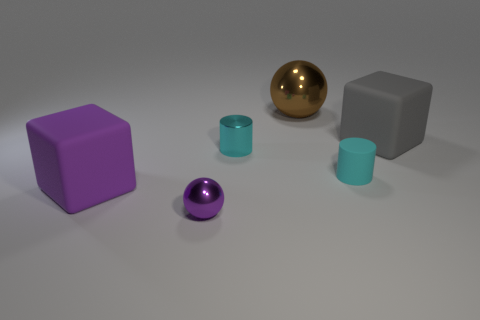How many things are things to the left of the cyan shiny cylinder or metal spheres behind the gray thing?
Make the answer very short. 3. Is the number of purple balls right of the tiny matte object the same as the number of big things in front of the big metal sphere?
Make the answer very short. No. There is a thing that is in front of the large rubber thing in front of the small metallic cylinder; what shape is it?
Offer a very short reply. Sphere. Are there any large purple rubber objects of the same shape as the big gray object?
Your response must be concise. Yes. What number of purple objects are there?
Provide a succinct answer. 2. Is the cube that is to the left of the brown shiny object made of the same material as the big gray block?
Keep it short and to the point. Yes. Is there another thing that has the same size as the gray object?
Provide a short and direct response. Yes. There is a large brown metal thing; is its shape the same as the shiny thing on the left side of the cyan metal cylinder?
Your response must be concise. Yes. There is a large rubber object to the left of the large gray matte block behind the cyan rubber cylinder; are there any spheres that are left of it?
Make the answer very short. No. How big is the cyan metal cylinder?
Give a very brief answer. Small. 